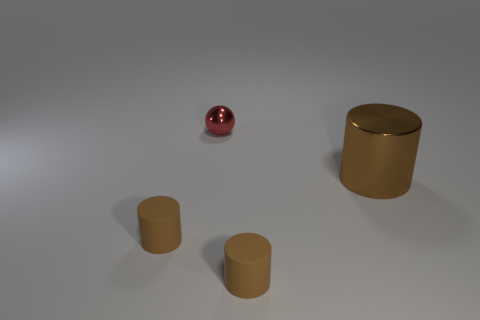What number of other things are the same shape as the large thing?
Provide a short and direct response. 2. There is a cylinder that is both to the right of the small red metallic thing and in front of the big cylinder; what is its material?
Provide a succinct answer. Rubber. What number of things are small cylinders or yellow cylinders?
Offer a terse response. 2. Are there more red spheres than tiny brown rubber cylinders?
Keep it short and to the point. No. There is a metallic object right of the small rubber object that is to the right of the red shiny thing; what is its size?
Offer a terse response. Large. What is the size of the brown metal thing?
Your response must be concise. Large. What number of cubes are either small brown things or large brown objects?
Give a very brief answer. 0. What number of small red matte cylinders are there?
Make the answer very short. 0. There is a small red metal thing; does it have the same shape as the brown matte object on the left side of the red object?
Offer a terse response. No. There is a brown object that is left of the red object; how big is it?
Give a very brief answer. Small. 